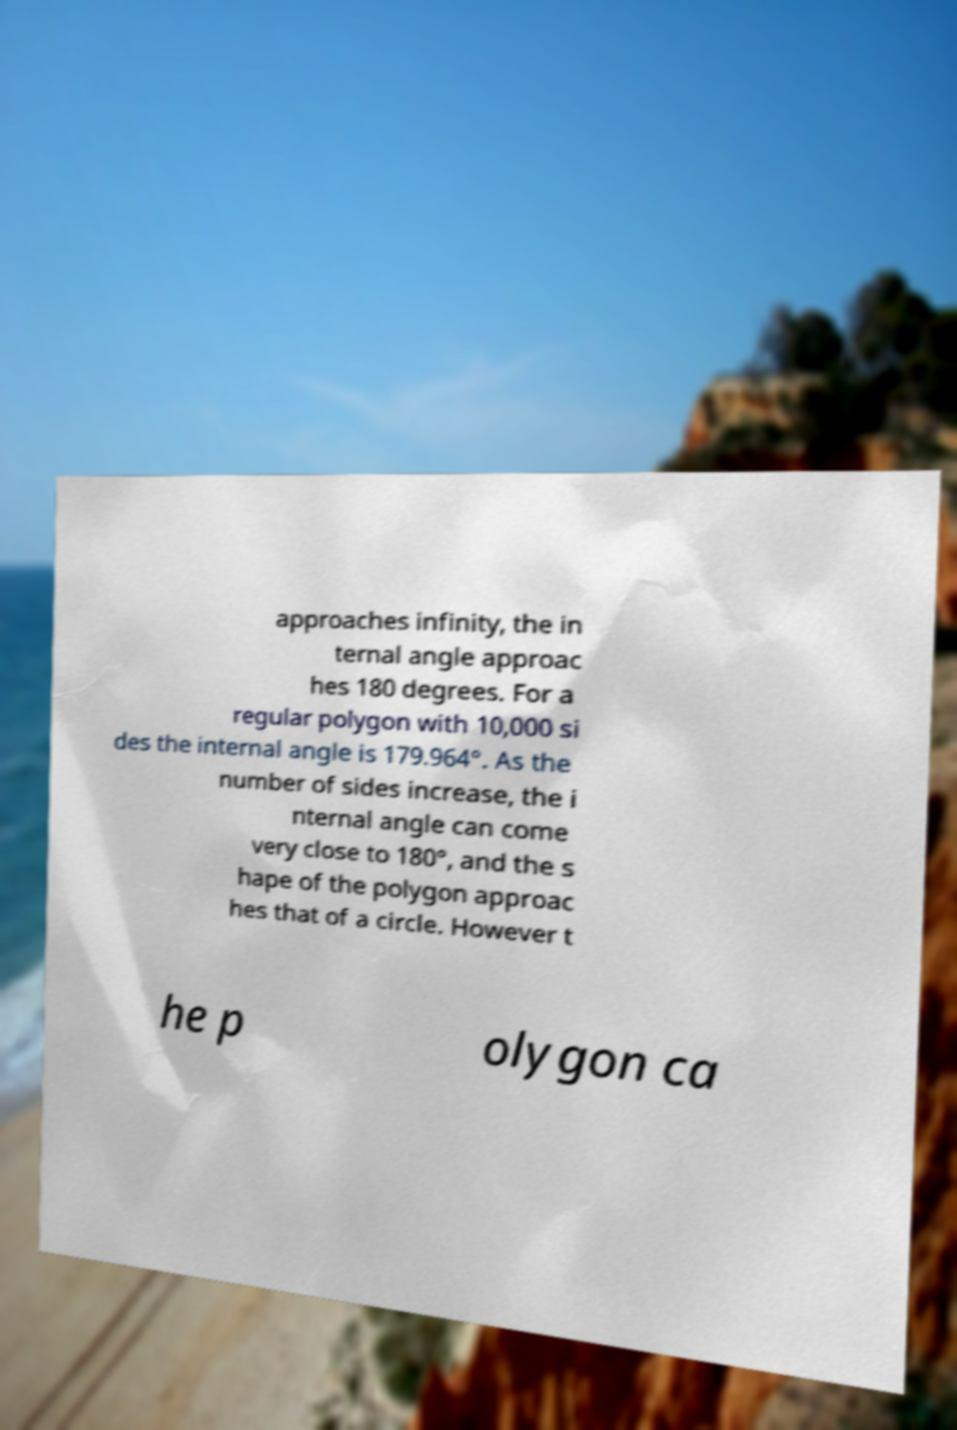For documentation purposes, I need the text within this image transcribed. Could you provide that? approaches infinity, the in ternal angle approac hes 180 degrees. For a regular polygon with 10,000 si des the internal angle is 179.964°. As the number of sides increase, the i nternal angle can come very close to 180°, and the s hape of the polygon approac hes that of a circle. However t he p olygon ca 